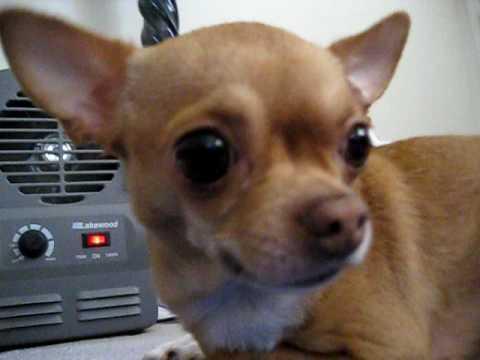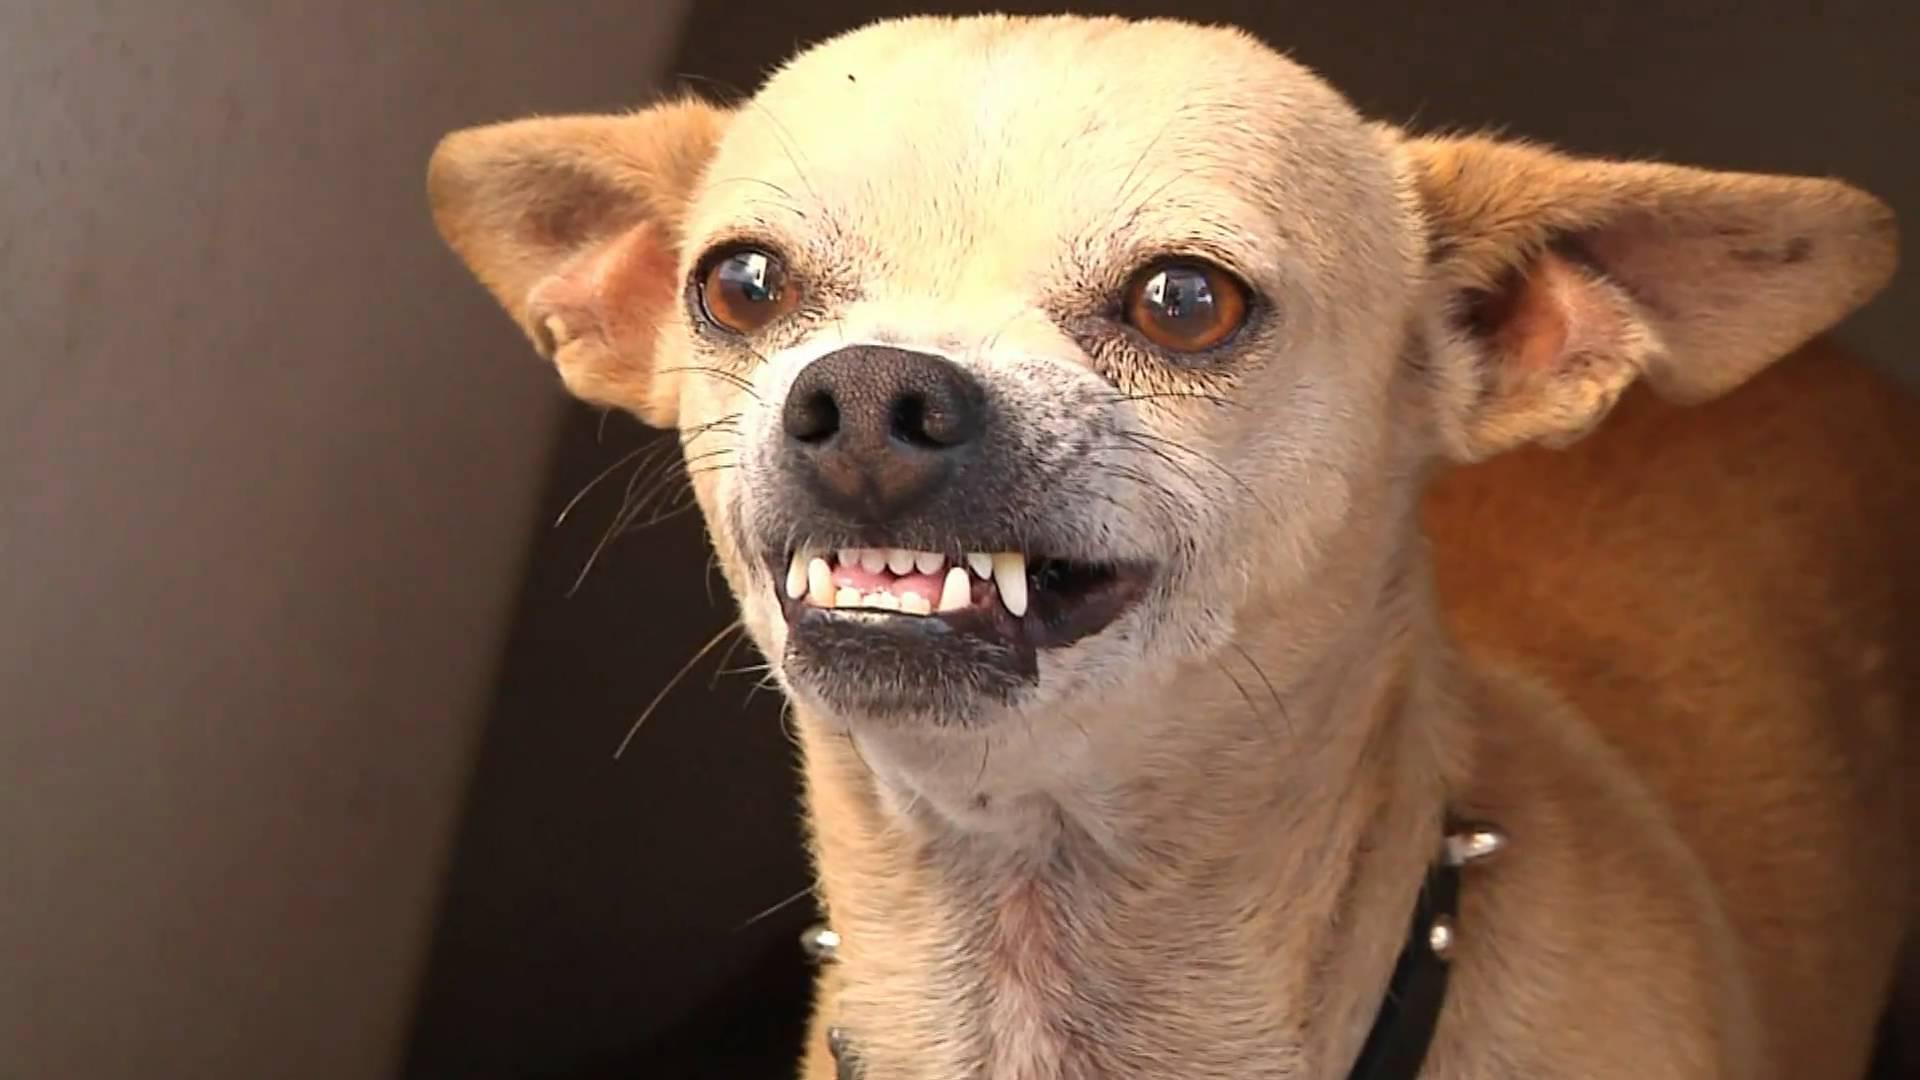The first image is the image on the left, the second image is the image on the right. Assess this claim about the two images: "The dog in the image on the left is baring its teeth.". Correct or not? Answer yes or no. No. The first image is the image on the left, the second image is the image on the right. Evaluate the accuracy of this statement regarding the images: "There is only one dog baring its teeth, in total.". Is it true? Answer yes or no. Yes. 